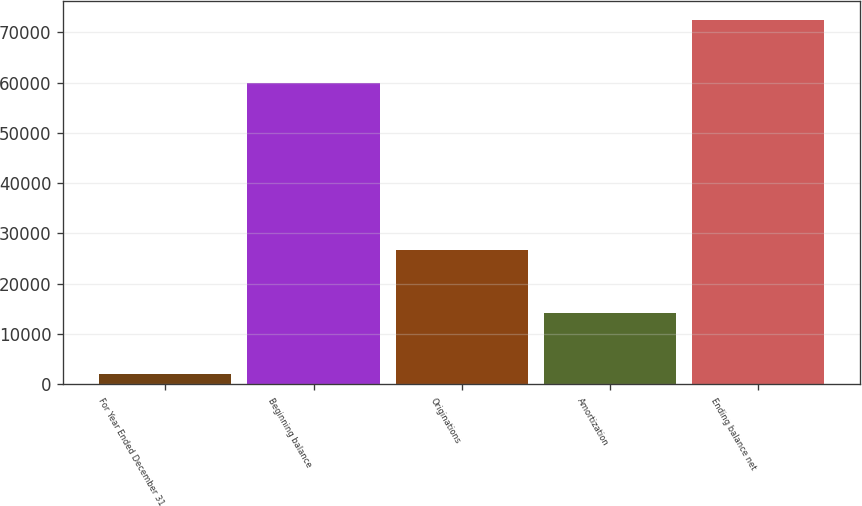Convert chart. <chart><loc_0><loc_0><loc_500><loc_500><bar_chart><fcel>For Year Ended December 31<fcel>Beginning balance<fcel>Originations<fcel>Amortization<fcel>Ending balance net<nl><fcel>2013<fcel>59978<fcel>26754<fcel>14233<fcel>72499<nl></chart> 